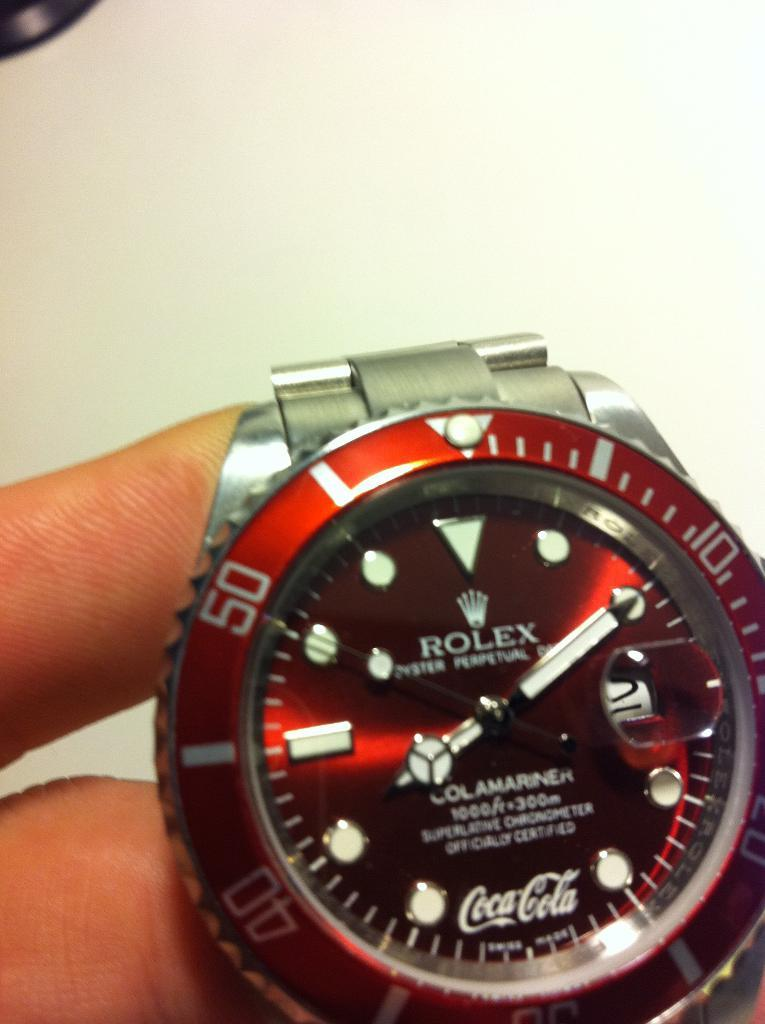<image>
Give a short and clear explanation of the subsequent image. The face of a Rolex watch is red with the Coca Cola logo at the bottom. 